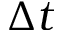<formula> <loc_0><loc_0><loc_500><loc_500>\Delta t</formula> 